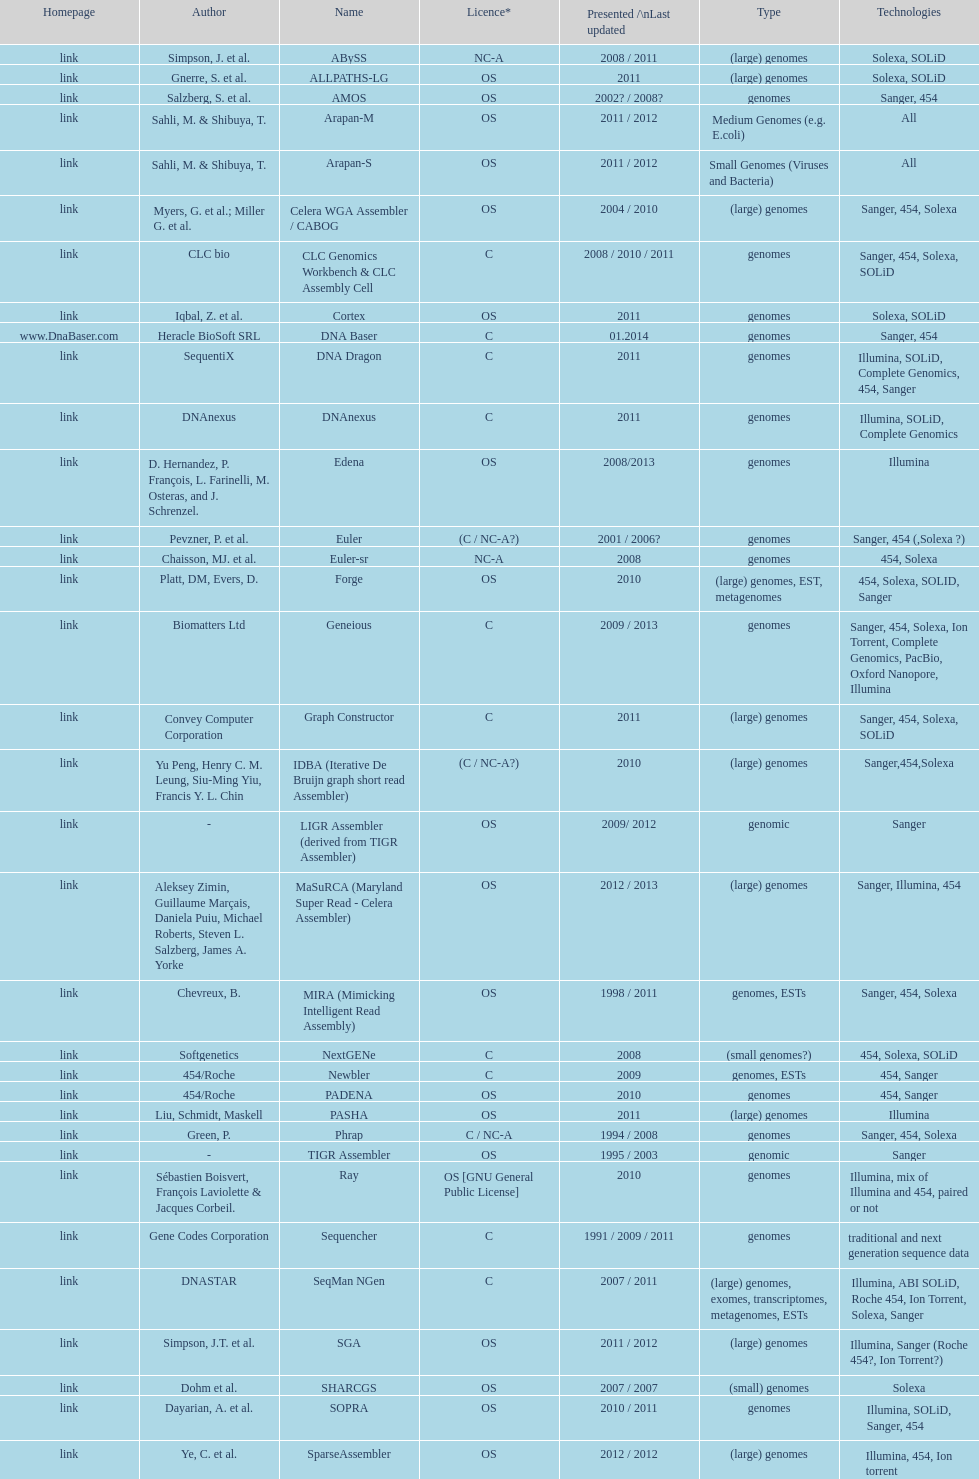Could you parse the entire table? {'header': ['Homepage', 'Author', 'Name', 'Licence*', 'Presented /\\nLast updated', 'Type', 'Technologies'], 'rows': [['link', 'Simpson, J. et al.', 'ABySS', 'NC-A', '2008 / 2011', '(large) genomes', 'Solexa, SOLiD'], ['link', 'Gnerre, S. et al.', 'ALLPATHS-LG', 'OS', '2011', '(large) genomes', 'Solexa, SOLiD'], ['link', 'Salzberg, S. et al.', 'AMOS', 'OS', '2002? / 2008?', 'genomes', 'Sanger, 454'], ['link', 'Sahli, M. & Shibuya, T.', 'Arapan-M', 'OS', '2011 / 2012', 'Medium Genomes (e.g. E.coli)', 'All'], ['link', 'Sahli, M. & Shibuya, T.', 'Arapan-S', 'OS', '2011 / 2012', 'Small Genomes (Viruses and Bacteria)', 'All'], ['link', 'Myers, G. et al.; Miller G. et al.', 'Celera WGA Assembler / CABOG', 'OS', '2004 / 2010', '(large) genomes', 'Sanger, 454, Solexa'], ['link', 'CLC bio', 'CLC Genomics Workbench & CLC Assembly Cell', 'C', '2008 / 2010 / 2011', 'genomes', 'Sanger, 454, Solexa, SOLiD'], ['link', 'Iqbal, Z. et al.', 'Cortex', 'OS', '2011', 'genomes', 'Solexa, SOLiD'], ['www.DnaBaser.com', 'Heracle BioSoft SRL', 'DNA Baser', 'C', '01.2014', 'genomes', 'Sanger, 454'], ['link', 'SequentiX', 'DNA Dragon', 'C', '2011', 'genomes', 'Illumina, SOLiD, Complete Genomics, 454, Sanger'], ['link', 'DNAnexus', 'DNAnexus', 'C', '2011', 'genomes', 'Illumina, SOLiD, Complete Genomics'], ['link', 'D. Hernandez, P. François, L. Farinelli, M. Osteras, and J. Schrenzel.', 'Edena', 'OS', '2008/2013', 'genomes', 'Illumina'], ['link', 'Pevzner, P. et al.', 'Euler', '(C / NC-A?)', '2001 / 2006?', 'genomes', 'Sanger, 454 (,Solexa\xa0?)'], ['link', 'Chaisson, MJ. et al.', 'Euler-sr', 'NC-A', '2008', 'genomes', '454, Solexa'], ['link', 'Platt, DM, Evers, D.', 'Forge', 'OS', '2010', '(large) genomes, EST, metagenomes', '454, Solexa, SOLID, Sanger'], ['link', 'Biomatters Ltd', 'Geneious', 'C', '2009 / 2013', 'genomes', 'Sanger, 454, Solexa, Ion Torrent, Complete Genomics, PacBio, Oxford Nanopore, Illumina'], ['link', 'Convey Computer Corporation', 'Graph Constructor', 'C', '2011', '(large) genomes', 'Sanger, 454, Solexa, SOLiD'], ['link', 'Yu Peng, Henry C. M. Leung, Siu-Ming Yiu, Francis Y. L. Chin', 'IDBA (Iterative De Bruijn graph short read Assembler)', '(C / NC-A?)', '2010', '(large) genomes', 'Sanger,454,Solexa'], ['link', '-', 'LIGR Assembler (derived from TIGR Assembler)', 'OS', '2009/ 2012', 'genomic', 'Sanger'], ['link', 'Aleksey Zimin, Guillaume Marçais, Daniela Puiu, Michael Roberts, Steven L. Salzberg, James A. Yorke', 'MaSuRCA (Maryland Super Read - Celera Assembler)', 'OS', '2012 / 2013', '(large) genomes', 'Sanger, Illumina, 454'], ['link', 'Chevreux, B.', 'MIRA (Mimicking Intelligent Read Assembly)', 'OS', '1998 / 2011', 'genomes, ESTs', 'Sanger, 454, Solexa'], ['link', 'Softgenetics', 'NextGENe', 'C', '2008', '(small genomes?)', '454, Solexa, SOLiD'], ['link', '454/Roche', 'Newbler', 'C', '2009', 'genomes, ESTs', '454, Sanger'], ['link', '454/Roche', 'PADENA', 'OS', '2010', 'genomes', '454, Sanger'], ['link', 'Liu, Schmidt, Maskell', 'PASHA', 'OS', '2011', '(large) genomes', 'Illumina'], ['link', 'Green, P.', 'Phrap', 'C / NC-A', '1994 / 2008', 'genomes', 'Sanger, 454, Solexa'], ['link', '-', 'TIGR Assembler', 'OS', '1995 / 2003', 'genomic', 'Sanger'], ['link', 'Sébastien Boisvert, François Laviolette & Jacques Corbeil.', 'Ray', 'OS [GNU General Public License]', '2010', 'genomes', 'Illumina, mix of Illumina and 454, paired or not'], ['link', 'Gene Codes Corporation', 'Sequencher', 'C', '1991 / 2009 / 2011', 'genomes', 'traditional and next generation sequence data'], ['link', 'DNASTAR', 'SeqMan NGen', 'C', '2007 / 2011', '(large) genomes, exomes, transcriptomes, metagenomes, ESTs', 'Illumina, ABI SOLiD, Roche 454, Ion Torrent, Solexa, Sanger'], ['link', 'Simpson, J.T. et al.', 'SGA', 'OS', '2011 / 2012', '(large) genomes', 'Illumina, Sanger (Roche 454?, Ion Torrent?)'], ['link', 'Dohm et al.', 'SHARCGS', 'OS', '2007 / 2007', '(small) genomes', 'Solexa'], ['link', 'Dayarian, A. et al.', 'SOPRA', 'OS', '2010 / 2011', 'genomes', 'Illumina, SOLiD, Sanger, 454'], ['link', 'Ye, C. et al.', 'SparseAssembler', 'OS', '2012 / 2012', '(large) genomes', 'Illumina, 454, Ion torrent'], ['link', 'Warren, R. et al.', 'SSAKE', 'OS', '2007 / 2007', '(small) genomes', 'Solexa (SOLiD? Helicos?)'], ['link', 'Li, R. et al.', 'SOAPdenovo', 'OS', '2009 / 2009', 'genomes', 'Solexa'], ['link', 'Bankevich, A et al.', 'SPAdes', 'OS', '2012 / 2013', '(small) genomes, single-cell', 'Illumina, Solexa'], ['link', 'Staden et al.', 'Staden gap4 package', 'OS', '1991 / 2008', 'BACs (, small genomes?)', 'Sanger'], ['link', 'Schmidt, B. et al.', 'Taipan', 'OS', '2009', '(small) genomes', 'Illumina'], ['link', 'Jeck, W. et al.', 'VCAKE', 'OS', '2007 / 2007', '(small) genomes', 'Solexa (SOLiD?, Helicos?)'], ['link', 'Mullikin JC, et al.', 'Phusion assembler', 'OS', '2003', '(large) genomes', 'Sanger'], ['link', 'Bryant DW, et al.', 'Quality Value Guided SRA (QSRA)', 'OS', '2009', 'genomes', 'Sanger, Solexa'], ['link', 'Zerbino, D. et al.', 'Velvet', 'OS', '2007 / 2009', '(small) genomes', 'Sanger, 454, Solexa, SOLiD']]} When was the velvet last updated? 2009. 